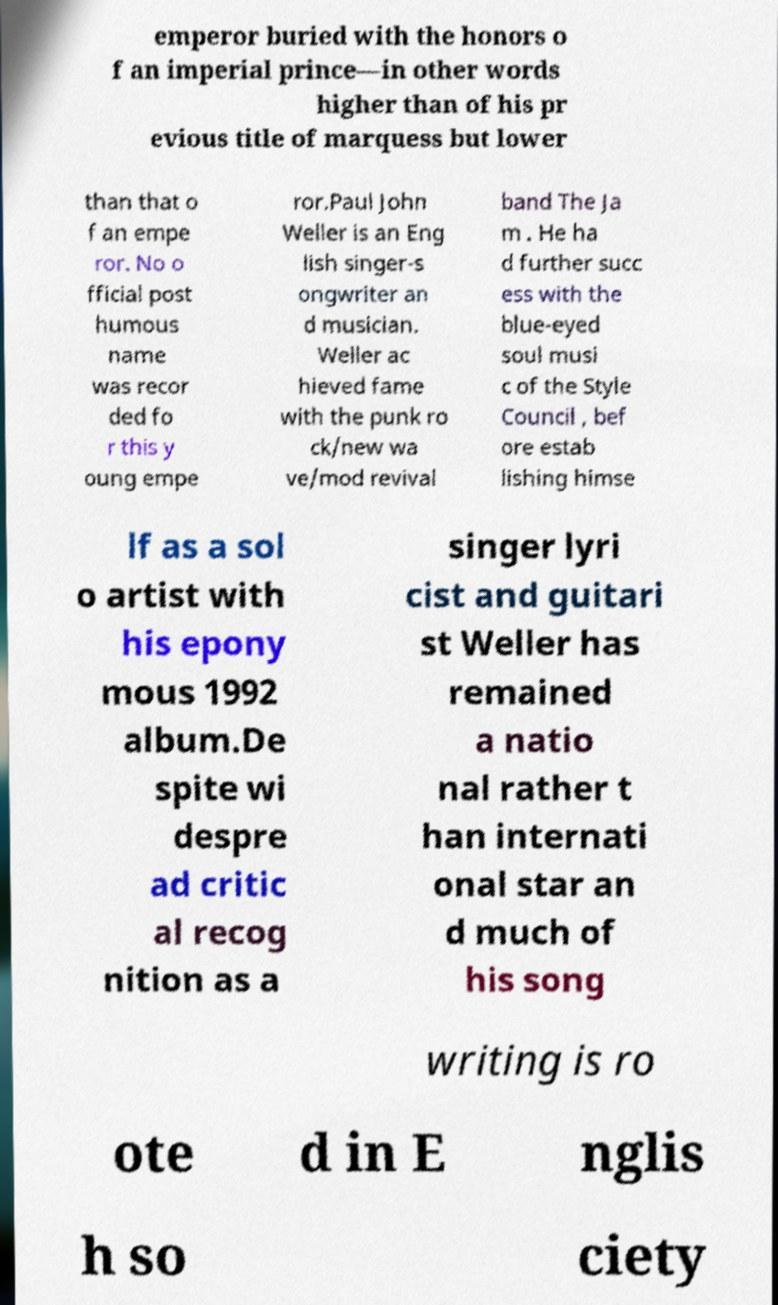Can you accurately transcribe the text from the provided image for me? emperor buried with the honors o f an imperial prince—in other words higher than of his pr evious title of marquess but lower than that o f an empe ror. No o fficial post humous name was recor ded fo r this y oung empe ror.Paul John Weller is an Eng lish singer-s ongwriter an d musician. Weller ac hieved fame with the punk ro ck/new wa ve/mod revival band The Ja m . He ha d further succ ess with the blue-eyed soul musi c of the Style Council , bef ore estab lishing himse lf as a sol o artist with his epony mous 1992 album.De spite wi despre ad critic al recog nition as a singer lyri cist and guitari st Weller has remained a natio nal rather t han internati onal star an d much of his song writing is ro ote d in E nglis h so ciety 